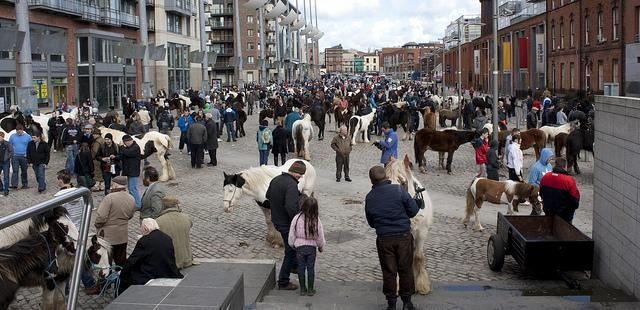What animal are the people checking out? horses 